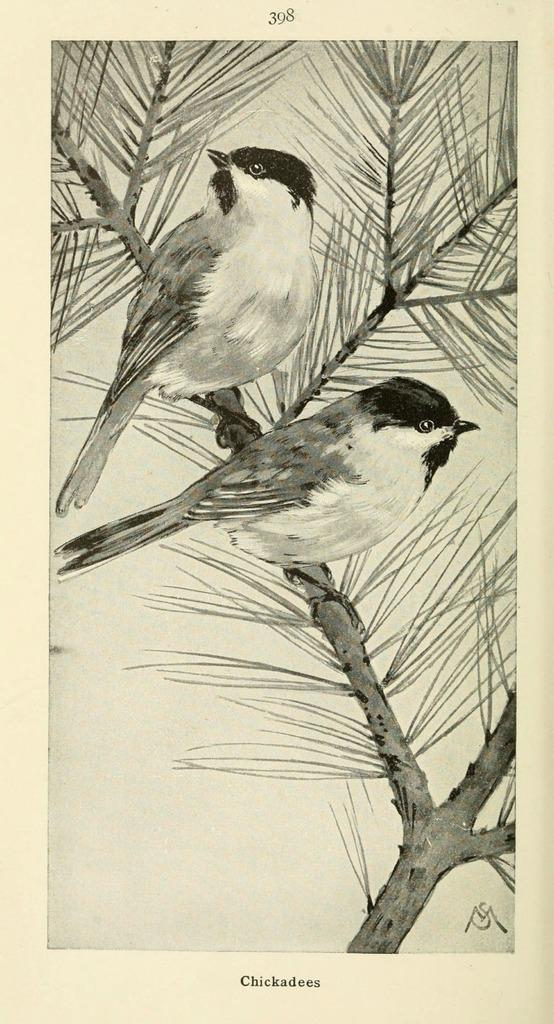What type of image is being described? The image is a drawing. What can be seen in the center of the drawing? There are two birds in the center of the image. Where are the birds located in the drawing? The birds are on a tree. What color is the background of the drawing? The background of the image is white. What is present at the top and bottom of the drawing? There is text at the top and bottom of the image. How does the learning process take place in the image? There is no learning process depicted in the image; it is a drawing of two birds on a tree with a white background and text at the top and bottom. 